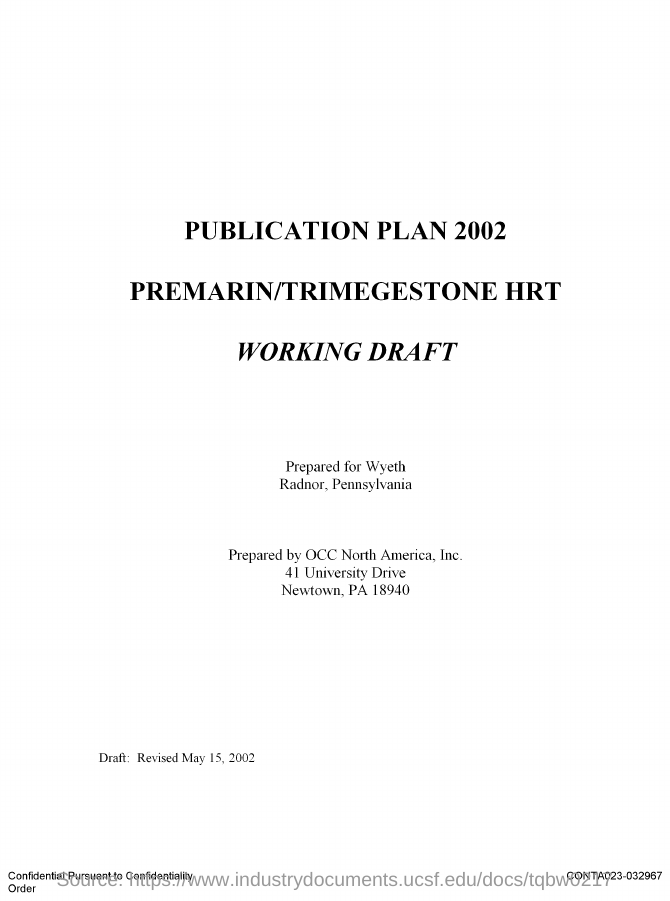Indicate a few pertinent items in this graphic. The ZIP code is 18940. 